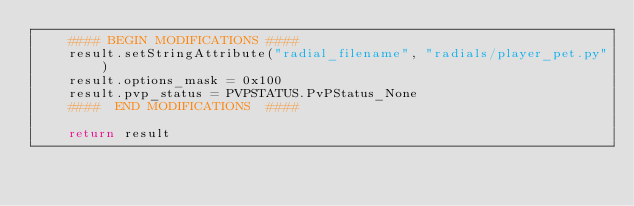Convert code to text. <code><loc_0><loc_0><loc_500><loc_500><_Python_>	#### BEGIN MODIFICATIONS ####
	result.setStringAttribute("radial_filename", "radials/player_pet.py")
	result.options_mask = 0x100
	result.pvp_status = PVPSTATUS.PvPStatus_None
	####  END MODIFICATIONS  ####
	
	return result
</code> 